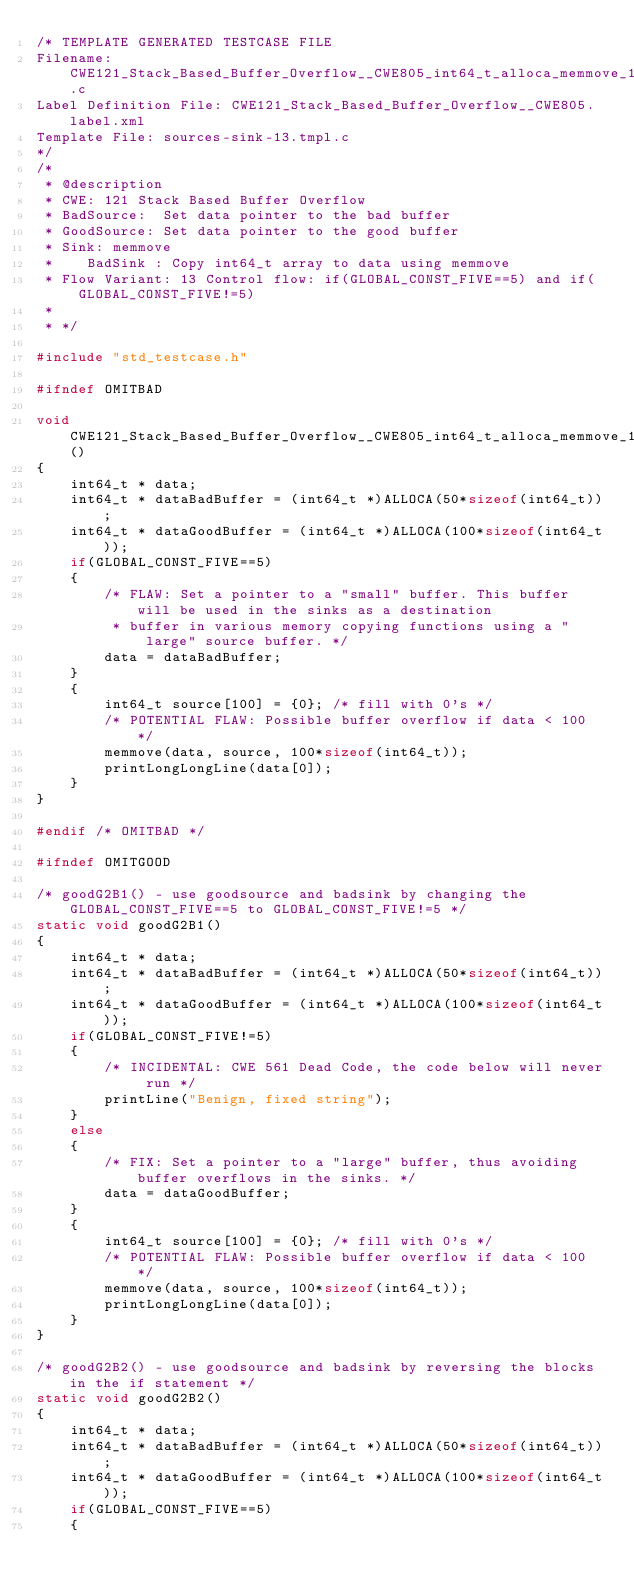<code> <loc_0><loc_0><loc_500><loc_500><_C_>/* TEMPLATE GENERATED TESTCASE FILE
Filename: CWE121_Stack_Based_Buffer_Overflow__CWE805_int64_t_alloca_memmove_13.c
Label Definition File: CWE121_Stack_Based_Buffer_Overflow__CWE805.label.xml
Template File: sources-sink-13.tmpl.c
*/
/*
 * @description
 * CWE: 121 Stack Based Buffer Overflow
 * BadSource:  Set data pointer to the bad buffer
 * GoodSource: Set data pointer to the good buffer
 * Sink: memmove
 *    BadSink : Copy int64_t array to data using memmove
 * Flow Variant: 13 Control flow: if(GLOBAL_CONST_FIVE==5) and if(GLOBAL_CONST_FIVE!=5)
 *
 * */

#include "std_testcase.h"

#ifndef OMITBAD

void CWE121_Stack_Based_Buffer_Overflow__CWE805_int64_t_alloca_memmove_13_bad()
{
    int64_t * data;
    int64_t * dataBadBuffer = (int64_t *)ALLOCA(50*sizeof(int64_t));
    int64_t * dataGoodBuffer = (int64_t *)ALLOCA(100*sizeof(int64_t));
    if(GLOBAL_CONST_FIVE==5)
    {
        /* FLAW: Set a pointer to a "small" buffer. This buffer will be used in the sinks as a destination
         * buffer in various memory copying functions using a "large" source buffer. */
        data = dataBadBuffer;
    }
    {
        int64_t source[100] = {0}; /* fill with 0's */
        /* POTENTIAL FLAW: Possible buffer overflow if data < 100 */
        memmove(data, source, 100*sizeof(int64_t));
        printLongLongLine(data[0]);
    }
}

#endif /* OMITBAD */

#ifndef OMITGOOD

/* goodG2B1() - use goodsource and badsink by changing the GLOBAL_CONST_FIVE==5 to GLOBAL_CONST_FIVE!=5 */
static void goodG2B1()
{
    int64_t * data;
    int64_t * dataBadBuffer = (int64_t *)ALLOCA(50*sizeof(int64_t));
    int64_t * dataGoodBuffer = (int64_t *)ALLOCA(100*sizeof(int64_t));
    if(GLOBAL_CONST_FIVE!=5)
    {
        /* INCIDENTAL: CWE 561 Dead Code, the code below will never run */
        printLine("Benign, fixed string");
    }
    else
    {
        /* FIX: Set a pointer to a "large" buffer, thus avoiding buffer overflows in the sinks. */
        data = dataGoodBuffer;
    }
    {
        int64_t source[100] = {0}; /* fill with 0's */
        /* POTENTIAL FLAW: Possible buffer overflow if data < 100 */
        memmove(data, source, 100*sizeof(int64_t));
        printLongLongLine(data[0]);
    }
}

/* goodG2B2() - use goodsource and badsink by reversing the blocks in the if statement */
static void goodG2B2()
{
    int64_t * data;
    int64_t * dataBadBuffer = (int64_t *)ALLOCA(50*sizeof(int64_t));
    int64_t * dataGoodBuffer = (int64_t *)ALLOCA(100*sizeof(int64_t));
    if(GLOBAL_CONST_FIVE==5)
    {</code> 